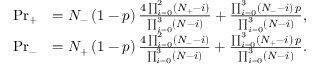Convert formula to latex. <formula><loc_0><loc_0><loc_500><loc_500>\begin{array} { r l } { P r _ { + } } & { = N _ { - } \left ( 1 - p \right ) \frac { 4 \prod _ { i = 0 } ^ { 2 } \left ( N _ { + } - i \right ) } { \prod _ { i = 0 } ^ { 3 } \left ( N - i \right ) } + \frac { \prod _ { i = 0 } ^ { 3 } \left ( N _ { - } - i \right ) \, p } { \prod _ { i = 0 } ^ { 3 } \left ( N - i \right ) } , } \\ { P r _ { - } } & { = N _ { + } \left ( 1 - p \right ) \frac { 4 \prod _ { i = 0 } ^ { 2 } \left ( N _ { - } - i \right ) } { \prod _ { i = 0 } ^ { 3 } \left ( N - i \right ) } + \frac { \prod _ { i = 0 } ^ { 3 } \left ( N _ { + } - i \right ) \, p } { \prod _ { i = 0 } ^ { 3 } \left ( N - i \right ) } . } \end{array}</formula> 